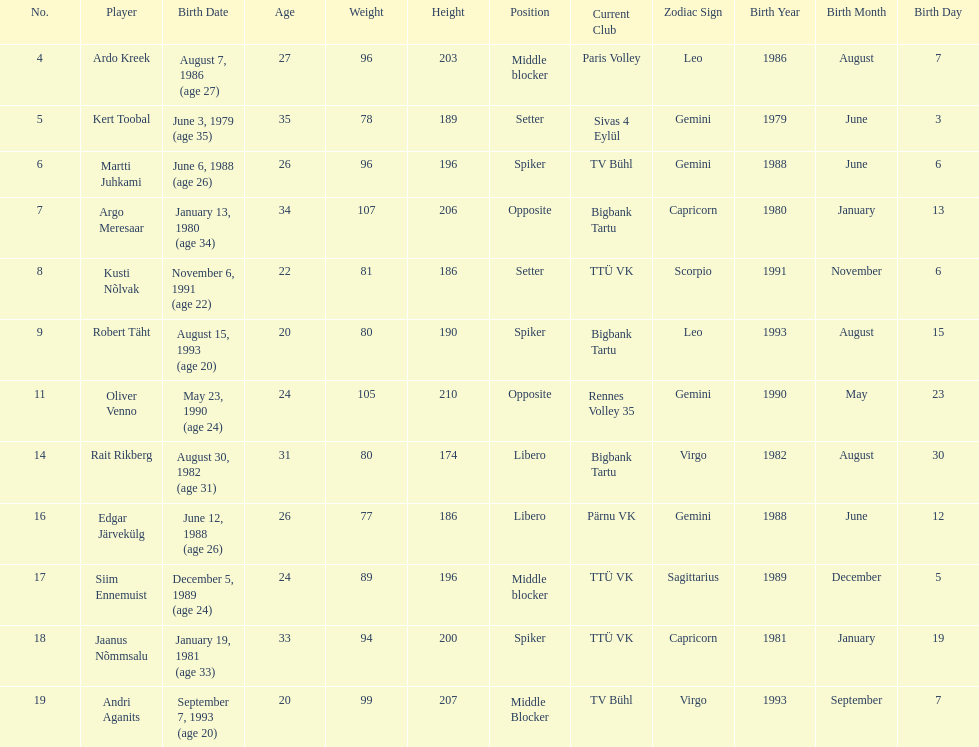Who is the tallest member of estonia's men's national volleyball team? Oliver Venno. 